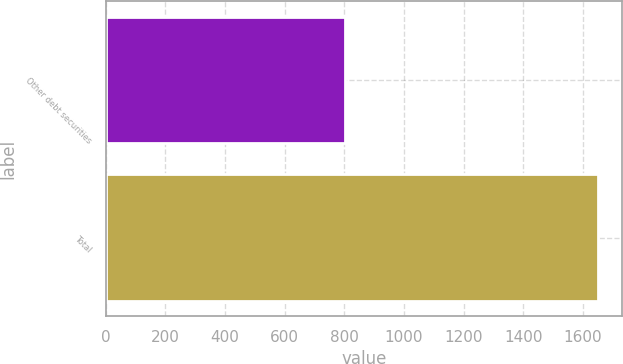<chart> <loc_0><loc_0><loc_500><loc_500><bar_chart><fcel>Other debt securities<fcel>Total<nl><fcel>801.7<fcel>1649.9<nl></chart> 